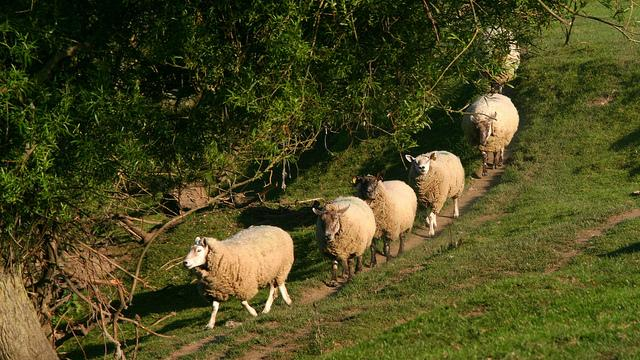What are the animals walking along?

Choices:
A) trail
B) sidewalk
C) fence
D) rubble trail 